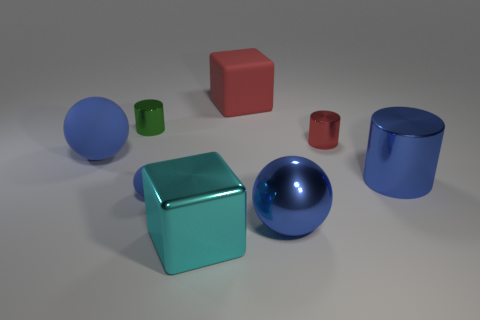How many blue spheres must be subtracted to get 1 blue spheres? 2 Subtract 1 cylinders. How many cylinders are left? 2 Add 2 large cylinders. How many objects exist? 10 Subtract all cylinders. How many objects are left? 5 Add 5 blue metallic balls. How many blue metallic balls are left? 6 Add 5 blue cylinders. How many blue cylinders exist? 6 Subtract 0 yellow cubes. How many objects are left? 8 Subtract all small red matte things. Subtract all blue metal cylinders. How many objects are left? 7 